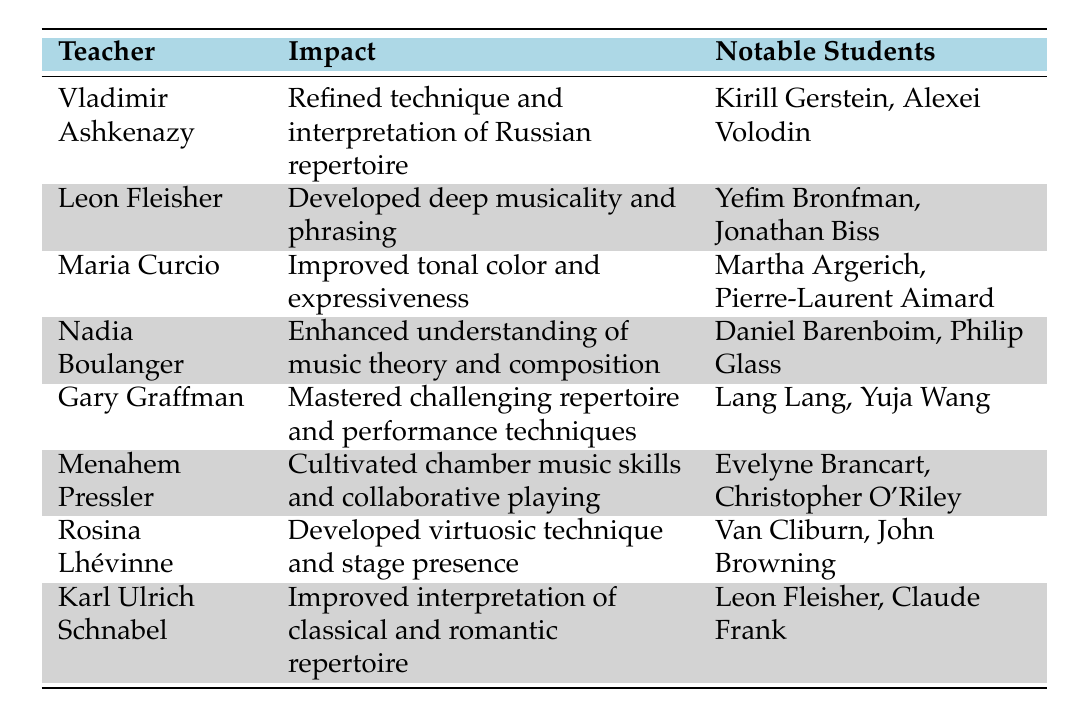What impact did Vladimir Ashkenazy have on his students? The table states that Vladimir Ashkenazy refined technique and interpretation of Russian repertoire.
Answer: Refined technique and interpretation of Russian repertoire Who are the notable students of Maria Curcio? According to the table, Maria Curcio's notable students are Martha Argerich and Pierre-Laurent Aimard.
Answer: Martha Argerich, Pierre-Laurent Aimard Did Leon Fleisher teach any students who are also notable teachers? Yes, the table shows that Leon Fleisher is a notable student of Karl Ulrich Schnabel, who is also listed as a teacher.
Answer: Yes Which teacher had an impact on mastering challenging repertoire and performance techniques? The table indicates that Gary Graffman had an impact on mastering challenging repertoire and performance techniques.
Answer: Gary Graffman How many notable students did Nadia Boulanger teach? The table lists two notable students for Nadia Boulanger: Daniel Barenboim and Philip Glass, so the count is 2.
Answer: 2 Which teacher is associated with the development of deep musicality and phrasing? Leon Fleisher is noted for developing deep musicality and phrasing according to the table.
Answer: Leon Fleisher Identify the teacher whose students include Lang Lang and Yuja Wang. From the table, Gary Graffman is the teacher who had students Lang Lang and Yuja Wang.
Answer: Gary Graffman What is the common impact shared by both Rosina Lhévinne and Menahem Pressler? Both have impacts related to performance skills: Rosina Lhévinne developed virtuosic technique and stage presence, while Menahem Pressler cultivated chamber music skills and collaborative playing, but they focus on different aspects.
Answer: They focus on performance skills, but different aspects Which teacher has the most notable students mentioned? The table lists notable students for several teachers but does not specify a numerical comparison, thus requires interpretation. If we judge by those having famous students, both Maria Curcio and Gary Graffman have widely recognized students.
Answer: Tie between Maria Curcio and Gary Graffman 